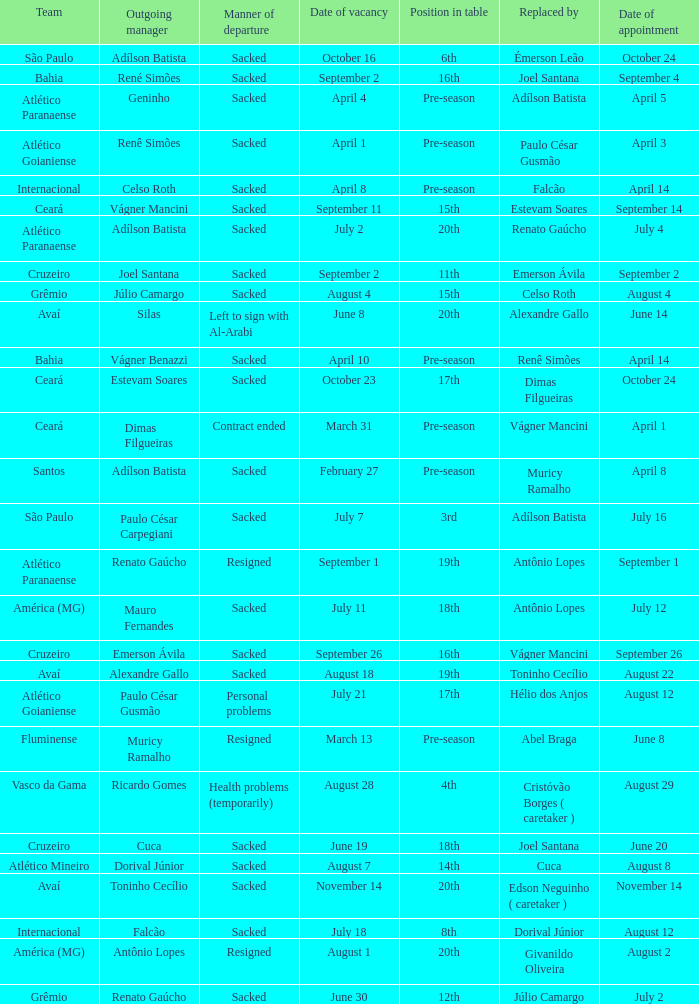Who was the new Santos manager? Muricy Ramalho. 